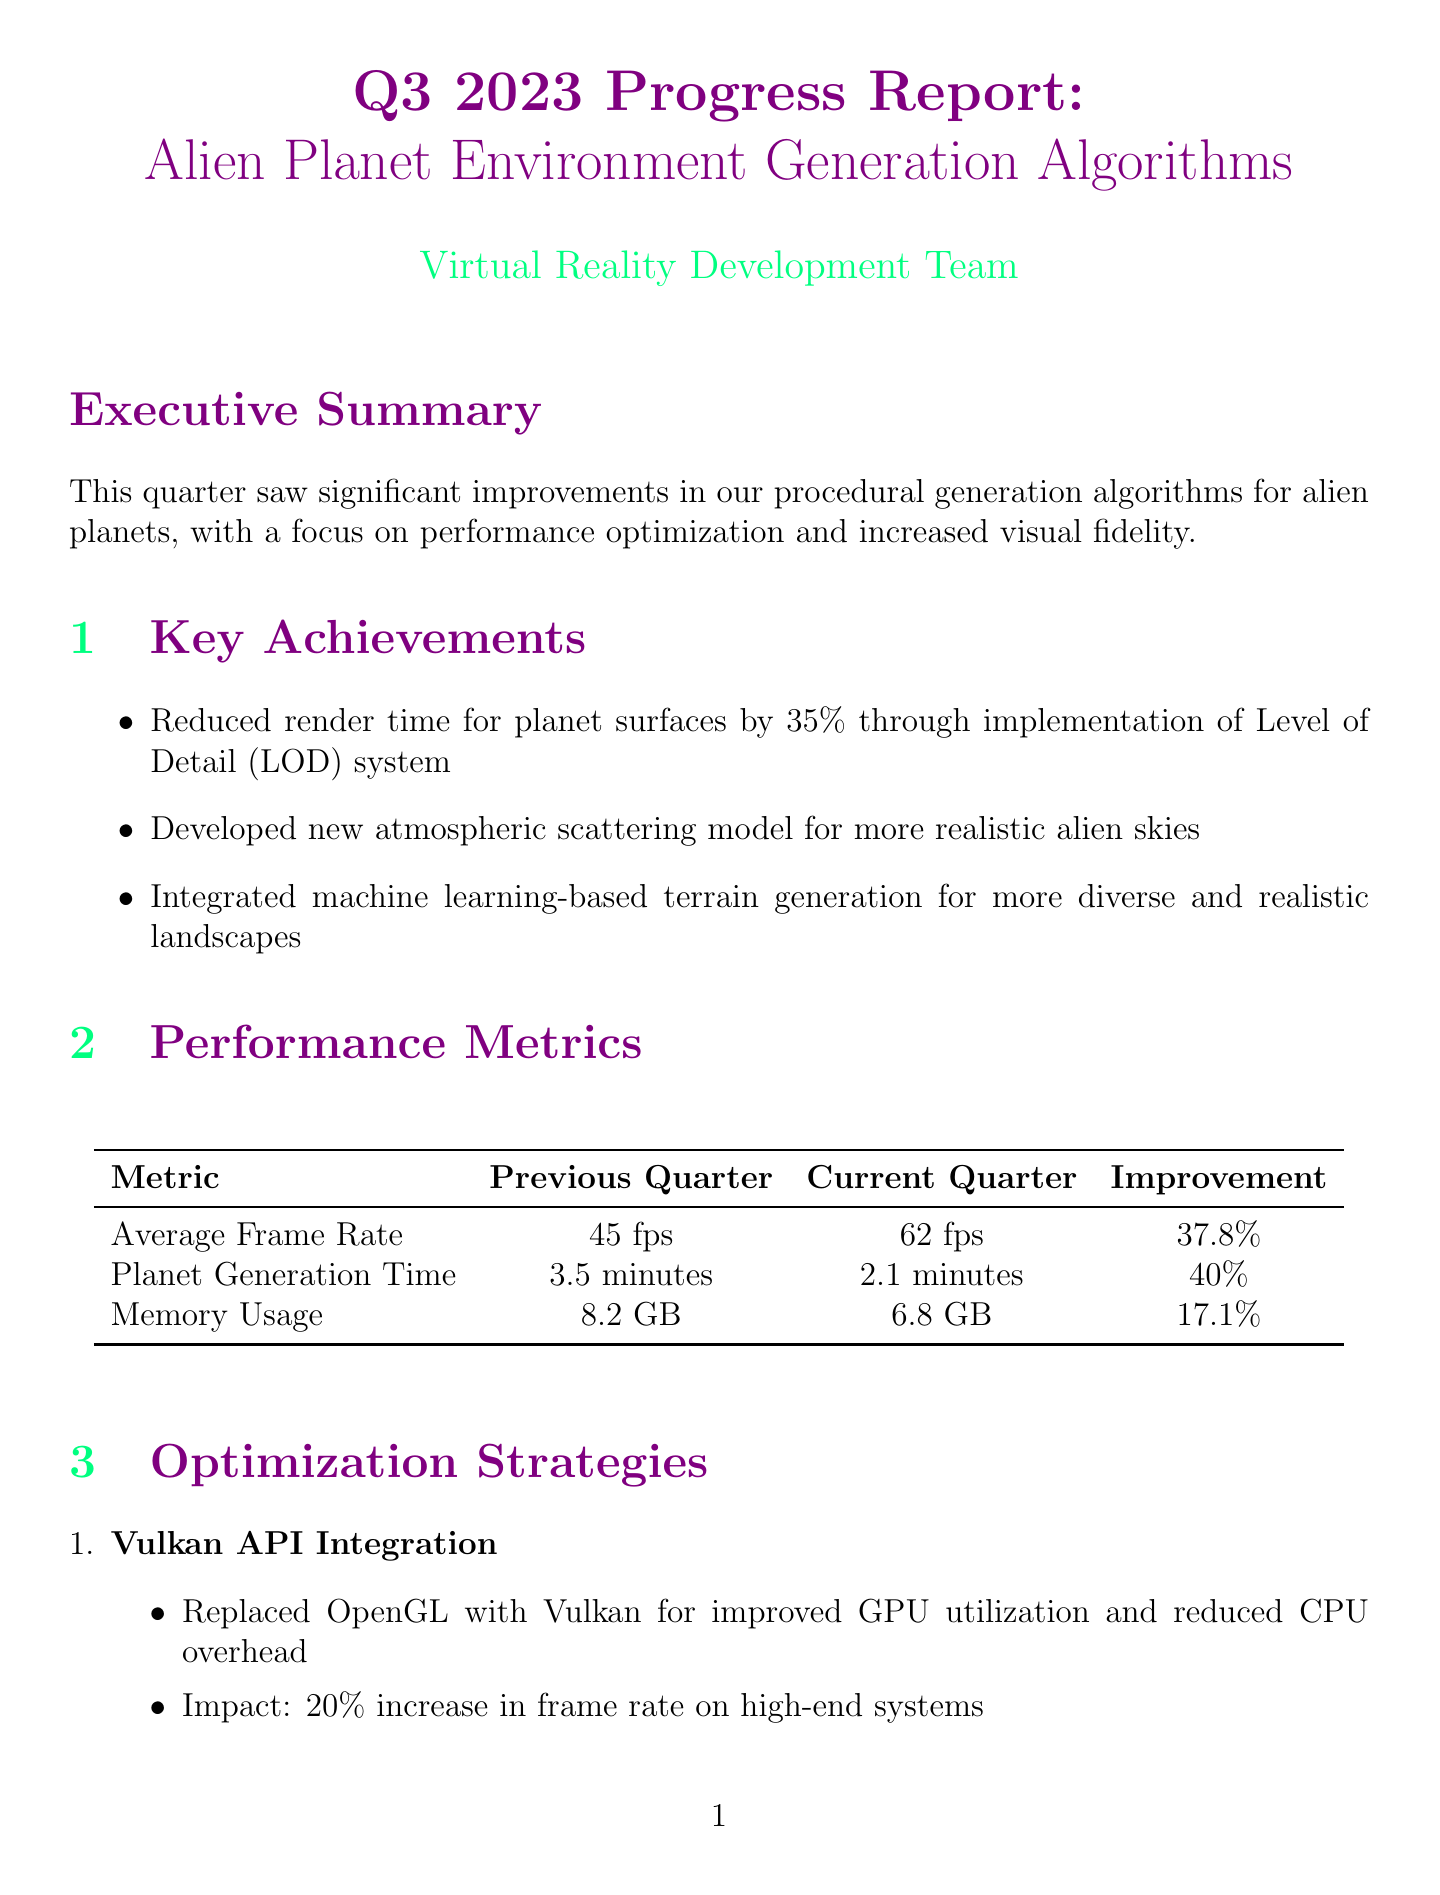what was the average frame rate in the previous quarter? The previous average frame rate is listed as 45 fps in the performance metrics section.
Answer: 45 fps what is the improvement percentage for planet generation time? The improvement for planet generation time is detailed as 40% in the performance metrics section.
Answer: 40% what major challenge was identified regarding mid-range hardware? The challenge noted in the report is related to GPU memory limitations on mid-range hardware.
Answer: GPU memory limitations on mid-range hardware what is the impact of integrating Vulkan API? The impact of integrating Vulkan API is stated as a 20% increase in frame rate on high-end systems.
Answer: 20% increase in frame rate what feature is 90% complete? The feature that is 90% complete and undergoing final testing is the Dynamic Weather System.
Answer: Dynamic Weather System how much was the reduced texture memory usage due to procedural texture compression? The reduced texture memory usage by implementing procedural texture compression is noted as 45%.
Answer: 45% what upcoming focus area is related to NVIDIA technology? The upcoming focus area related to NVIDIA technology is the integration of NVIDIA DLSS for improved performance on RTX graphics cards.
Answer: Integration of NVIDIA DLSS what was a solution to unrealistic alien flora distribution? The solution implemented for unrealistic alien flora distribution is the development of an ecosystem simulation algorithm based on alien planet parameters.
Answer: Developed ecosystem simulation algorithm 